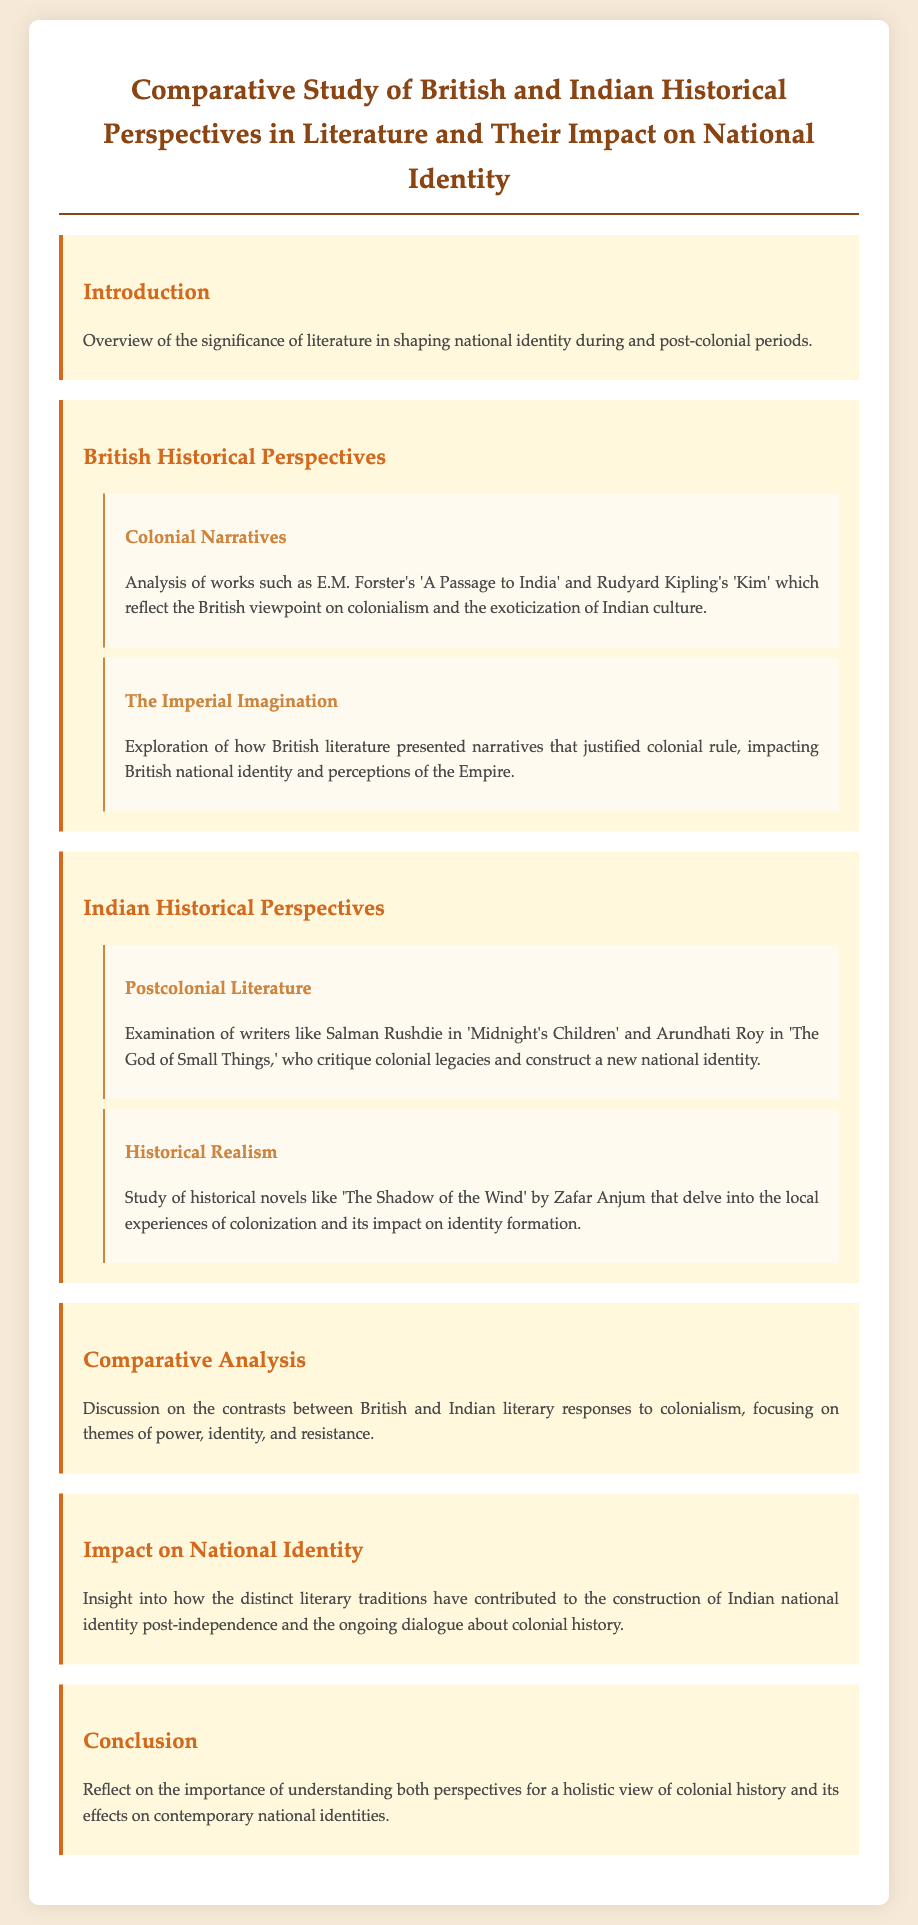What is the title of the document? The title is prominently displayed at the top of the document, which provides a clear overview of its focus on literature and history.
Answer: Comparative Study of British and Indian Historical Perspectives in Literature and Their Impact on National Identity Who wrote 'A Passage to India'? The document mentions E.M. Forster as the author of 'A Passage to India', highlighting a significant British literary work.
Answer: E.M. Forster Which Indian writer is associated with 'Midnight's Children'? The document identifies Salman Rushdie as the writer of 'Midnight's Children', showcasing a key figure in postcolonial literature.
Answer: Salman Rushdie What theme is explored in the Comparative Analysis section? The Comparative Analysis section discusses contrasts between British and Indian responses to colonialism, specifically focusing on power, identity, and resistance.
Answer: Power, identity, and resistance What literary work examines local experiences of colonization? The document refers to 'The Shadow of the Wind' by Zafar Anjum as a work that delves into local experiences during colonization.
Answer: The Shadow of the Wind What impact does the document say literature has had on national identity? The document notes the contribution of distinct literary traditions to the construction of Indian national identity post-independence.
Answer: Construction of Indian national identity How is the Imperial Imagination described? The text describes it as a narrative that justified colonial rule and affected perceptions of the Empire within British literature.
Answer: Justified colonial rule Which section addresses Works of a Postcolonial nature? The Indian Historical Perspectives section covers Postcolonial Literature, analyzing writers who critique colonial legacies.
Answer: Indian Historical Perspectives What is the conclusion's focus? The conclusion emphasizes the importance of understanding both British and Indian perspectives for a holistic view of colonial history.
Answer: Understanding both perspectives 